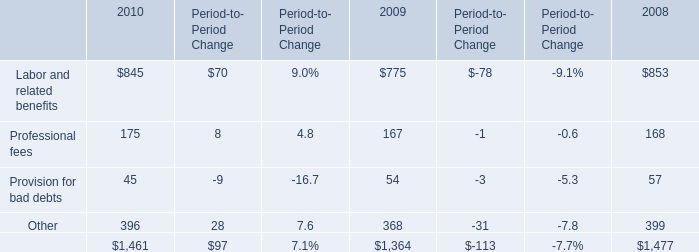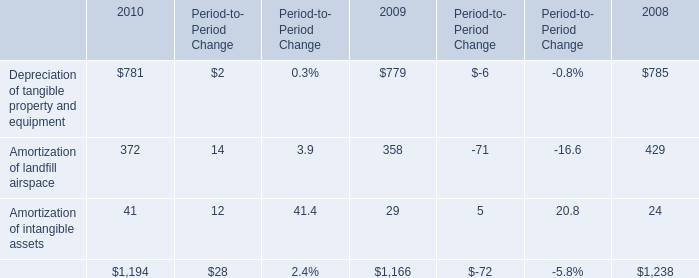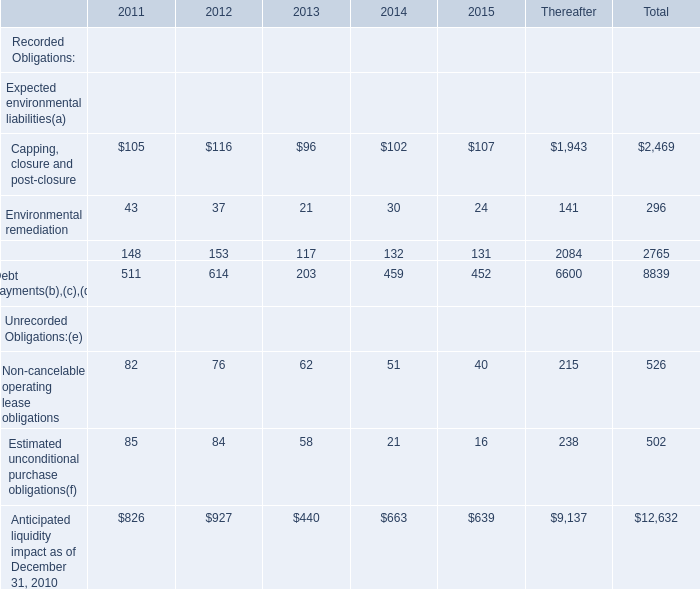In the year with the most Capping, closure and post-closure, what is the growth rate of Environmental remediation? 
Computations: ((37 - 21) / 21)
Answer: 0.7619. 